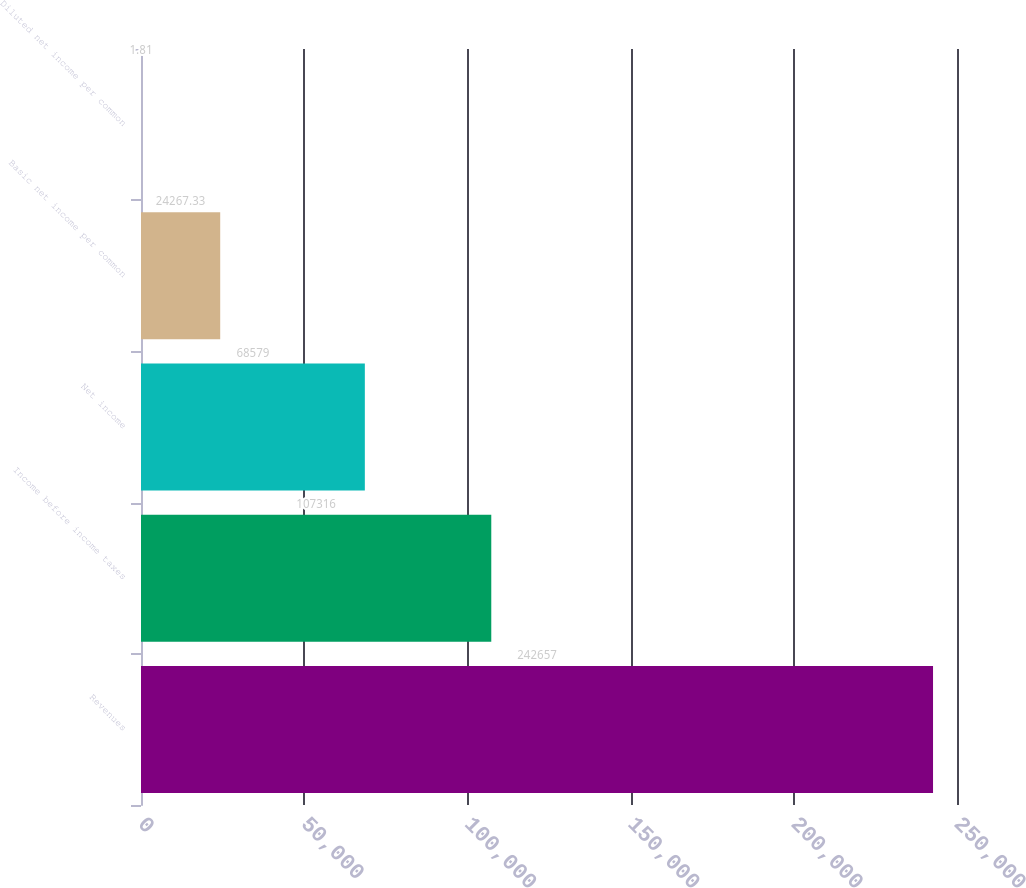Convert chart. <chart><loc_0><loc_0><loc_500><loc_500><bar_chart><fcel>Revenues<fcel>Income before income taxes<fcel>Net income<fcel>Basic net income per common<fcel>Diluted net income per common<nl><fcel>242657<fcel>107316<fcel>68579<fcel>24267.3<fcel>1.81<nl></chart> 